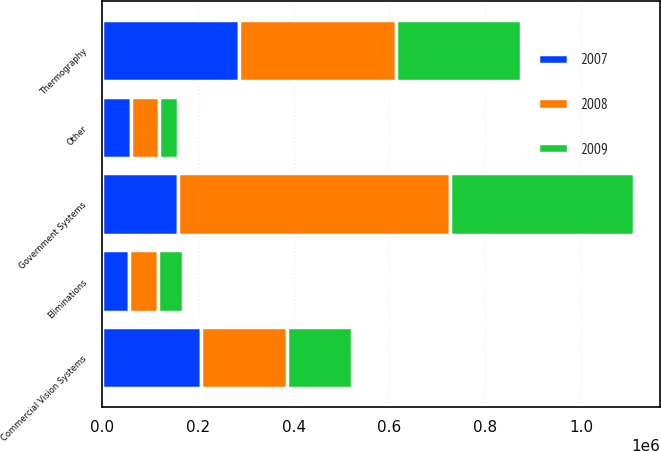<chart> <loc_0><loc_0><loc_500><loc_500><stacked_bar_chart><ecel><fcel>Government Systems<fcel>Thermography<fcel>Commercial Vision Systems<fcel>Eliminations<fcel>Other<nl><fcel>2007<fcel>157920<fcel>285482<fcel>206323<fcel>56890<fcel>61293<nl><fcel>2008<fcel>569028<fcel>327324<fcel>180622<fcel>61301<fcel>57276<nl><fcel>2009<fcel>382347<fcel>261831<fcel>135219<fcel>51886<fcel>40931<nl></chart> 